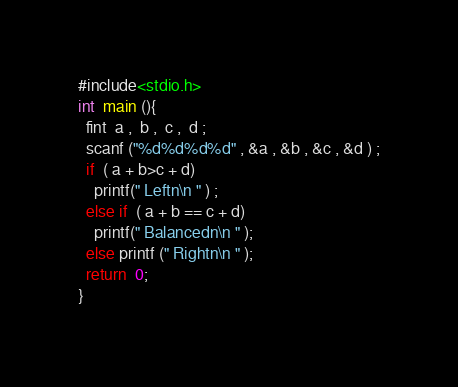Convert code to text. <code><loc_0><loc_0><loc_500><loc_500><_C_>#include<stdio.h>
int  main (){
  fint  a ,  b ,  c ,  d ;
  scanf ("%d%d%d%d" , &a , &b , &c , &d ) ;
  if  ( a + b>c + d) 
    printf(" Leftn\n " ) ;
  else if  ( a + b == c + d) 
    printf(" Balancedn\n " );
  else printf (" Rightn\n " );
  return  0;
}</code> 